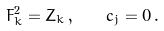<formula> <loc_0><loc_0><loc_500><loc_500>F _ { k } ^ { 2 } = Z _ { k } \, , \quad c _ { j } = 0 \, .</formula> 